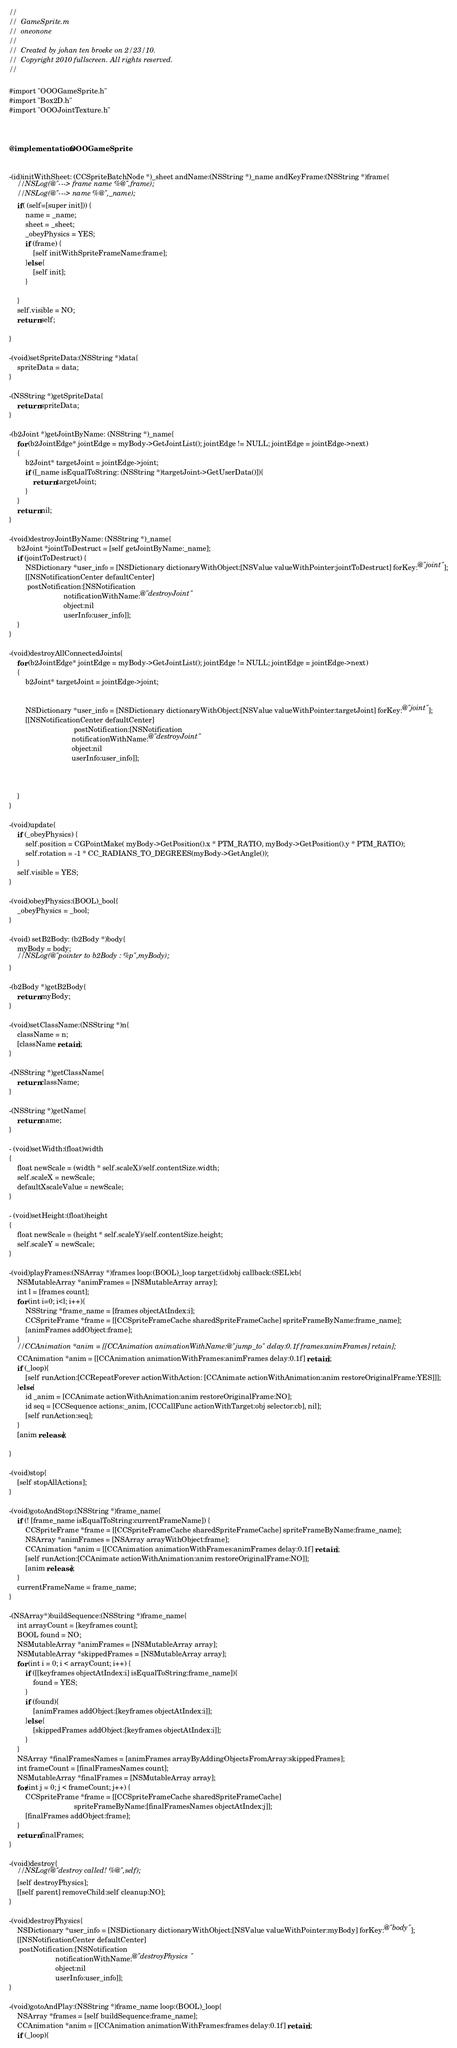<code> <loc_0><loc_0><loc_500><loc_500><_ObjectiveC_>//
//  GameSprite.m
//  oneonone
//
//  Created by johan ten broeke on 2/23/10.
//  Copyright 2010 fullscreen. All rights reserved.
//

#import "OOOGameSprite.h"
#import "Box2D.h"
#import "OOOJointTexture.h"



@implementation OOOGameSprite


-(id)initWithSheet: (CCSpriteBatchNode *)_sheet andName:(NSString *)_name andKeyFrame:(NSString *)frame{
	//NSLog(@"---> frame name %@",frame);
	//NSLog(@"---> name %@",_name);
	if( (self=[super init])) {
		name = _name;
		sheet = _sheet;
		_obeyPhysics = YES;
		if (frame) {
			[self initWithSpriteFrameName:frame];
		}else {
			[self init];
		}

	}
	self.visible = NO;
	return self;

}

-(void)setSpriteData:(NSString *)data{
	spriteData = data;
}

-(NSString *)getSpriteData{
	return spriteData;
}

-(b2Joint *)getJointByName: (NSString *)_name{
	for (b2JointEdge* jointEdge = myBody->GetJointList(); jointEdge != NULL; jointEdge = jointEdge->next)
	{
		b2Joint* targetJoint = jointEdge->joint;
		if ([_name isEqualToString: (NSString *)targetJoint->GetUserData()]){
			return targetJoint;
		}		
	}
	return nil;
}

-(void)destroyJointByName: (NSString *)_name{
	b2Joint *jointToDestruct = [self getJointByName:_name];
	if (jointToDestruct) {
		NSDictionary *user_info = [NSDictionary dictionaryWithObject:[NSValue valueWithPointer:jointToDestruct] forKey:@"joint"];
		[[NSNotificationCenter defaultCenter] 
		 postNotification:[NSNotification 
						   notificationWithName:@"destroyJoint" 
						   object:nil 
						   userInfo:user_info]];
	}
}

-(void)destroyAllConnectedJoints{
	for (b2JointEdge* jointEdge = myBody->GetJointList(); jointEdge != NULL; jointEdge = jointEdge->next)
	{
		b2Joint* targetJoint = jointEdge->joint;
		

		NSDictionary *user_info = [NSDictionary dictionaryWithObject:[NSValue valueWithPointer:targetJoint] forKey:@"joint"];
		[[NSNotificationCenter defaultCenter] 
								postNotification:[NSNotification 
							   notificationWithName:@"destroyJoint" 
							   object:nil 
							   userInfo:user_info]];

		
				
	}
}

-(void)update{
	if (_obeyPhysics) {
		self.position = CGPointMake( myBody->GetPosition().x * PTM_RATIO, myBody->GetPosition().y * PTM_RATIO);
		self.rotation = -1 * CC_RADIANS_TO_DEGREES(myBody->GetAngle());
	}
	self.visible = YES;
}

-(void)obeyPhysics:(BOOL)_bool{
	_obeyPhysics = _bool;
}

-(void) setB2Body: (b2Body *)body{
	myBody = body;
	//NSLog(@"pointer to b2Body : %p",myBody);
}

-(b2Body *)getB2Body{
	return myBody;
}

-(void)setClassName:(NSString *)n{
	className = n;
	[className retain];
}

-(NSString *)getClassName{
	return className;
}

-(NSString *)getName{
	return name;
}

- (void)setWidth:(float)width
{
	float newScale = (width * self.scaleX)/self.contentSize.width;
	self.scaleX = newScale;
	defaultXscaleValue = newScale;
}

- (void)setHeight:(float)height
{
	float newScale = (height * self.scaleY)/self.contentSize.height;
	self.scaleY = newScale;
}

-(void)playFrames:(NSArray *)frames loop:(BOOL)_loop target:(id)obj callback:(SEL)cb{
	NSMutableArray *animFrames = [NSMutableArray array];
	int l = [frames count];
	for (int i=0; i<l; i++){
		NSString *frame_name = [frames objectAtIndex:i]; 
		CCSpriteFrame *frame = [[CCSpriteFrameCache sharedSpriteFrameCache] spriteFrameByName:frame_name];
		[animFrames addObject:frame];
	}
	//CCAnimation *anim = [[CCAnimation animationWithName:@"jump_to" delay:0.1f frames:animFrames] retain];
	CCAnimation *anim = [[CCAnimation animationWithFrames:animFrames delay:0.1f] retain];
	if (_loop){
		[self runAction:[CCRepeatForever actionWithAction: [CCAnimate actionWithAnimation:anim restoreOriginalFrame:YES]]];
	}else{
		id _anim = [CCAnimate actionWithAnimation:anim restoreOriginalFrame:NO];
		id seq = [CCSequence actions:_anim, [CCCallFunc actionWithTarget:obj selector:cb], nil];
		[self runAction:seq];
	}
	[anim release];
	
}

-(void)stop{
	[self stopAllActions];
}

-(void)gotoAndStop:(NSString *)frame_name{
	if (! [frame_name isEqualToString:currentFrameName]) {
		CCSpriteFrame *frame = [[CCSpriteFrameCache sharedSpriteFrameCache] spriteFrameByName:frame_name];
		NSArray *animFrames = [NSArray arrayWithObject:frame];
		CCAnimation *anim = [[CCAnimation animationWithFrames:animFrames delay:0.1f] retain];
		[self runAction:[CCAnimate actionWithAnimation:anim restoreOriginalFrame:NO]];
		[anim release];
	}
	currentFrameName = frame_name;
}

-(NSArray*)buildSequence:(NSString *)frame_name{
	int arrayCount = [keyframes count];
	BOOL found = NO;
	NSMutableArray *animFrames = [NSMutableArray array];
	NSMutableArray *skippedFrames = [NSMutableArray array];
	for (int i = 0; i < arrayCount; i++) {
		if ([[keyframes objectAtIndex:i] isEqualToString:frame_name]){
			found = YES;
		}
		if (found){
			[animFrames addObject:[keyframes objectAtIndex:i]];
		}else {
			[skippedFrames addObject:[keyframes objectAtIndex:i]];
		}
	}
	NSArray *finalFramesNames = [animFrames arrayByAddingObjectsFromArray:skippedFrames];
	int frameCount = [finalFramesNames count];
	NSMutableArray *finalFrames = [NSMutableArray array];
	for(int j = 0; j < frameCount; j++) {
		CCSpriteFrame *frame = [[CCSpriteFrameCache sharedSpriteFrameCache] 
								spriteFrameByName:[finalFramesNames objectAtIndex:j]];
		[finalFrames addObject:frame];
	}
	return finalFrames;
}

-(void)destroy{
	//NSLog(@"destroy called! %@",self);
	[self destroyPhysics];
	[[self parent] removeChild:self cleanup:NO];
}

-(void)destroyPhysics{
	NSDictionary *user_info = [NSDictionary dictionaryWithObject:[NSValue valueWithPointer:myBody] forKey:@"body"];
	[[NSNotificationCenter defaultCenter] 
	 postNotification:[NSNotification 
					   notificationWithName:@"destroyPhysics" 
					   object:nil 
					   userInfo:user_info]];
}

-(void)gotoAndPlay:(NSString *)frame_name loop:(BOOL)_loop{
	NSArray *frames = [self buildSequence:frame_name];
	CCAnimation *anim = [[CCAnimation animationWithFrames:frames delay:0.1f] retain];
	if (_loop){</code> 